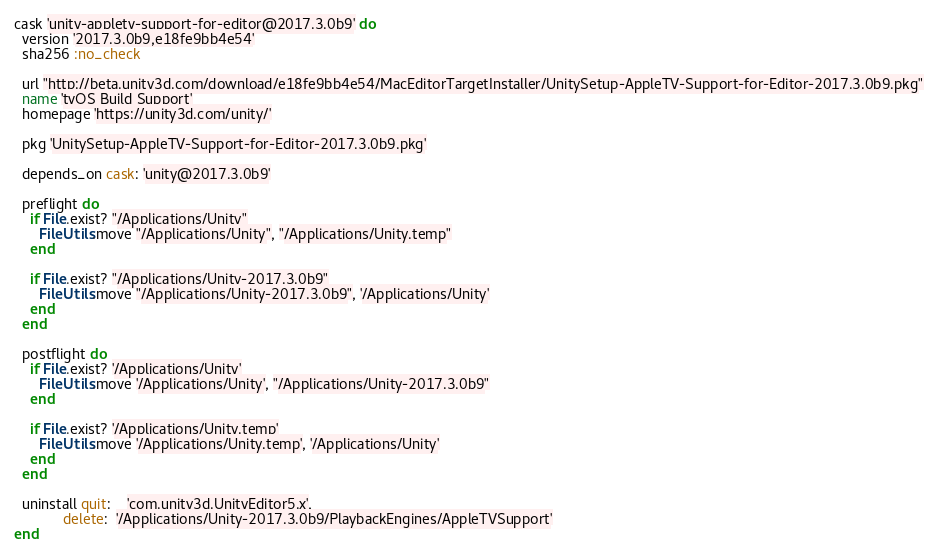<code> <loc_0><loc_0><loc_500><loc_500><_Ruby_>cask 'unity-appletv-support-for-editor@2017.3.0b9' do
  version '2017.3.0b9,e18fe9bb4e54'
  sha256 :no_check

  url "http://beta.unity3d.com/download/e18fe9bb4e54/MacEditorTargetInstaller/UnitySetup-AppleTV-Support-for-Editor-2017.3.0b9.pkg"
  name 'tvOS Build Support'
  homepage 'https://unity3d.com/unity/'

  pkg 'UnitySetup-AppleTV-Support-for-Editor-2017.3.0b9.pkg'

  depends_on cask: 'unity@2017.3.0b9'

  preflight do
    if File.exist? "/Applications/Unity"
      FileUtils.move "/Applications/Unity", "/Applications/Unity.temp"
    end

    if File.exist? "/Applications/Unity-2017.3.0b9"
      FileUtils.move "/Applications/Unity-2017.3.0b9", '/Applications/Unity'
    end
  end

  postflight do
    if File.exist? '/Applications/Unity'
      FileUtils.move '/Applications/Unity', "/Applications/Unity-2017.3.0b9"
    end

    if File.exist? '/Applications/Unity.temp'
      FileUtils.move '/Applications/Unity.temp', '/Applications/Unity'
    end
  end

  uninstall quit:    'com.unity3d.UnityEditor5.x',
            delete:  '/Applications/Unity-2017.3.0b9/PlaybackEngines/AppleTVSupport'
end
</code> 